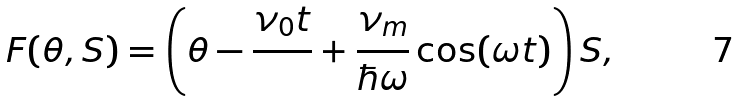Convert formula to latex. <formula><loc_0><loc_0><loc_500><loc_500>F ( \theta , S ) = \left ( \theta - \frac { \nu _ { 0 } t } { } + \frac { \nu _ { m } } { \hbar { \omega } } \cos ( \omega t ) \right ) S ,</formula> 